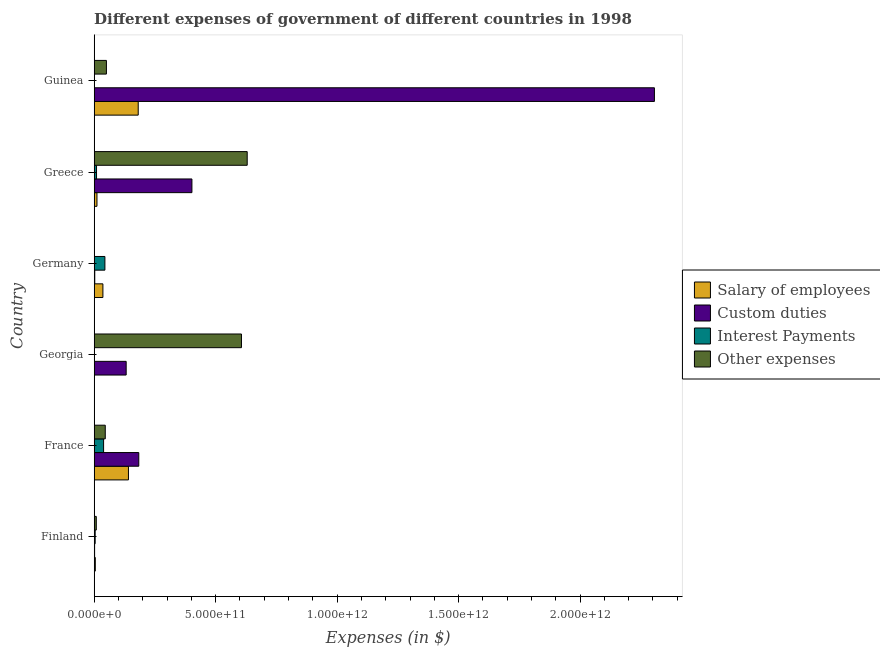How many different coloured bars are there?
Provide a short and direct response. 4. Are the number of bars per tick equal to the number of legend labels?
Give a very brief answer. Yes. Are the number of bars on each tick of the Y-axis equal?
Keep it short and to the point. Yes. How many bars are there on the 3rd tick from the top?
Make the answer very short. 4. How many bars are there on the 5th tick from the bottom?
Your answer should be very brief. 4. What is the label of the 2nd group of bars from the top?
Give a very brief answer. Greece. In how many cases, is the number of bars for a given country not equal to the number of legend labels?
Your response must be concise. 0. What is the amount spent on interest payments in Guinea?
Provide a succinct answer. 1.26e+09. Across all countries, what is the maximum amount spent on other expenses?
Ensure brevity in your answer.  6.30e+11. Across all countries, what is the minimum amount spent on other expenses?
Give a very brief answer. 7.21e+08. In which country was the amount spent on custom duties minimum?
Give a very brief answer. Finland. What is the total amount spent on interest payments in the graph?
Your answer should be very brief. 9.78e+1. What is the difference between the amount spent on salary of employees in Georgia and that in Guinea?
Make the answer very short. -1.81e+11. What is the difference between the amount spent on salary of employees in Germany and the amount spent on interest payments in France?
Your response must be concise. -2.83e+09. What is the average amount spent on interest payments per country?
Offer a very short reply. 1.63e+1. What is the difference between the amount spent on custom duties and amount spent on salary of employees in Germany?
Offer a terse response. -3.35e+1. What is the ratio of the amount spent on interest payments in France to that in Germany?
Keep it short and to the point. 0.88. What is the difference between the highest and the second highest amount spent on other expenses?
Provide a short and direct response. 2.36e+1. What is the difference between the highest and the lowest amount spent on other expenses?
Offer a very short reply. 6.29e+11. In how many countries, is the amount spent on custom duties greater than the average amount spent on custom duties taken over all countries?
Offer a very short reply. 1. Is the sum of the amount spent on interest payments in France and Germany greater than the maximum amount spent on other expenses across all countries?
Offer a terse response. No. Is it the case that in every country, the sum of the amount spent on interest payments and amount spent on other expenses is greater than the sum of amount spent on custom duties and amount spent on salary of employees?
Keep it short and to the point. No. What does the 3rd bar from the top in Germany represents?
Provide a short and direct response. Custom duties. What does the 1st bar from the bottom in Greece represents?
Provide a succinct answer. Salary of employees. Is it the case that in every country, the sum of the amount spent on salary of employees and amount spent on custom duties is greater than the amount spent on interest payments?
Provide a short and direct response. No. What is the difference between two consecutive major ticks on the X-axis?
Provide a succinct answer. 5.00e+11. Does the graph contain any zero values?
Provide a short and direct response. No. How many legend labels are there?
Give a very brief answer. 4. How are the legend labels stacked?
Make the answer very short. Vertical. What is the title of the graph?
Your answer should be very brief. Different expenses of government of different countries in 1998. What is the label or title of the X-axis?
Your answer should be very brief. Expenses (in $). What is the Expenses (in $) in Salary of employees in Finland?
Your answer should be very brief. 4.56e+09. What is the Expenses (in $) in Custom duties in Finland?
Ensure brevity in your answer.  1.68e+09. What is the Expenses (in $) in Interest Payments in Finland?
Make the answer very short. 4.01e+09. What is the Expenses (in $) in Other expenses in Finland?
Provide a short and direct response. 8.61e+09. What is the Expenses (in $) of Salary of employees in France?
Provide a succinct answer. 1.41e+11. What is the Expenses (in $) in Custom duties in France?
Offer a terse response. 1.84e+11. What is the Expenses (in $) in Interest Payments in France?
Your answer should be compact. 3.87e+1. What is the Expenses (in $) of Other expenses in France?
Provide a short and direct response. 4.56e+1. What is the Expenses (in $) of Salary of employees in Georgia?
Your answer should be compact. 8.04e+07. What is the Expenses (in $) in Custom duties in Georgia?
Provide a succinct answer. 1.32e+11. What is the Expenses (in $) in Interest Payments in Georgia?
Offer a very short reply. 1.28e+08. What is the Expenses (in $) in Other expenses in Georgia?
Keep it short and to the point. 6.06e+11. What is the Expenses (in $) of Salary of employees in Germany?
Your answer should be very brief. 3.58e+1. What is the Expenses (in $) of Custom duties in Germany?
Ensure brevity in your answer.  2.33e+09. What is the Expenses (in $) in Interest Payments in Germany?
Make the answer very short. 4.41e+1. What is the Expenses (in $) of Other expenses in Germany?
Keep it short and to the point. 7.21e+08. What is the Expenses (in $) in Salary of employees in Greece?
Your answer should be very brief. 1.14e+1. What is the Expenses (in $) in Custom duties in Greece?
Your answer should be very brief. 4.02e+11. What is the Expenses (in $) of Interest Payments in Greece?
Make the answer very short. 9.62e+09. What is the Expenses (in $) of Other expenses in Greece?
Ensure brevity in your answer.  6.30e+11. What is the Expenses (in $) in Salary of employees in Guinea?
Your answer should be very brief. 1.81e+11. What is the Expenses (in $) of Custom duties in Guinea?
Keep it short and to the point. 2.31e+12. What is the Expenses (in $) in Interest Payments in Guinea?
Give a very brief answer. 1.26e+09. What is the Expenses (in $) of Other expenses in Guinea?
Offer a very short reply. 5.03e+1. Across all countries, what is the maximum Expenses (in $) of Salary of employees?
Keep it short and to the point. 1.81e+11. Across all countries, what is the maximum Expenses (in $) in Custom duties?
Offer a very short reply. 2.31e+12. Across all countries, what is the maximum Expenses (in $) in Interest Payments?
Offer a terse response. 4.41e+1. Across all countries, what is the maximum Expenses (in $) of Other expenses?
Give a very brief answer. 6.30e+11. Across all countries, what is the minimum Expenses (in $) of Salary of employees?
Offer a very short reply. 8.04e+07. Across all countries, what is the minimum Expenses (in $) in Custom duties?
Your response must be concise. 1.68e+09. Across all countries, what is the minimum Expenses (in $) in Interest Payments?
Your answer should be very brief. 1.28e+08. Across all countries, what is the minimum Expenses (in $) of Other expenses?
Provide a succinct answer. 7.21e+08. What is the total Expenses (in $) in Salary of employees in the graph?
Offer a terse response. 3.74e+11. What is the total Expenses (in $) of Custom duties in the graph?
Ensure brevity in your answer.  3.03e+12. What is the total Expenses (in $) in Interest Payments in the graph?
Your answer should be compact. 9.78e+1. What is the total Expenses (in $) in Other expenses in the graph?
Give a very brief answer. 1.34e+12. What is the difference between the Expenses (in $) in Salary of employees in Finland and that in France?
Provide a succinct answer. -1.36e+11. What is the difference between the Expenses (in $) of Custom duties in Finland and that in France?
Make the answer very short. -1.82e+11. What is the difference between the Expenses (in $) in Interest Payments in Finland and that in France?
Your response must be concise. -3.47e+1. What is the difference between the Expenses (in $) in Other expenses in Finland and that in France?
Ensure brevity in your answer.  -3.69e+1. What is the difference between the Expenses (in $) in Salary of employees in Finland and that in Georgia?
Keep it short and to the point. 4.47e+09. What is the difference between the Expenses (in $) of Custom duties in Finland and that in Georgia?
Give a very brief answer. -1.30e+11. What is the difference between the Expenses (in $) in Interest Payments in Finland and that in Georgia?
Make the answer very short. 3.88e+09. What is the difference between the Expenses (in $) in Other expenses in Finland and that in Georgia?
Make the answer very short. -5.98e+11. What is the difference between the Expenses (in $) of Salary of employees in Finland and that in Germany?
Provide a succinct answer. -3.13e+1. What is the difference between the Expenses (in $) of Custom duties in Finland and that in Germany?
Ensure brevity in your answer.  -6.47e+08. What is the difference between the Expenses (in $) of Interest Payments in Finland and that in Germany?
Make the answer very short. -4.01e+1. What is the difference between the Expenses (in $) in Other expenses in Finland and that in Germany?
Give a very brief answer. 7.89e+09. What is the difference between the Expenses (in $) of Salary of employees in Finland and that in Greece?
Offer a very short reply. -6.83e+09. What is the difference between the Expenses (in $) in Custom duties in Finland and that in Greece?
Provide a succinct answer. -4.01e+11. What is the difference between the Expenses (in $) in Interest Payments in Finland and that in Greece?
Your answer should be very brief. -5.62e+09. What is the difference between the Expenses (in $) in Other expenses in Finland and that in Greece?
Your response must be concise. -6.21e+11. What is the difference between the Expenses (in $) of Salary of employees in Finland and that in Guinea?
Your response must be concise. -1.77e+11. What is the difference between the Expenses (in $) in Custom duties in Finland and that in Guinea?
Provide a short and direct response. -2.30e+12. What is the difference between the Expenses (in $) of Interest Payments in Finland and that in Guinea?
Your answer should be compact. 2.74e+09. What is the difference between the Expenses (in $) in Other expenses in Finland and that in Guinea?
Make the answer very short. -4.17e+1. What is the difference between the Expenses (in $) in Salary of employees in France and that in Georgia?
Provide a succinct answer. 1.41e+11. What is the difference between the Expenses (in $) in Custom duties in France and that in Georgia?
Keep it short and to the point. 5.19e+1. What is the difference between the Expenses (in $) of Interest Payments in France and that in Georgia?
Your response must be concise. 3.85e+1. What is the difference between the Expenses (in $) of Other expenses in France and that in Georgia?
Provide a short and direct response. -5.61e+11. What is the difference between the Expenses (in $) of Salary of employees in France and that in Germany?
Provide a succinct answer. 1.05e+11. What is the difference between the Expenses (in $) of Custom duties in France and that in Germany?
Your response must be concise. 1.81e+11. What is the difference between the Expenses (in $) of Interest Payments in France and that in Germany?
Keep it short and to the point. -5.44e+09. What is the difference between the Expenses (in $) of Other expenses in France and that in Germany?
Keep it short and to the point. 4.48e+1. What is the difference between the Expenses (in $) in Salary of employees in France and that in Greece?
Give a very brief answer. 1.30e+11. What is the difference between the Expenses (in $) in Custom duties in France and that in Greece?
Provide a short and direct response. -2.19e+11. What is the difference between the Expenses (in $) of Interest Payments in France and that in Greece?
Keep it short and to the point. 2.90e+1. What is the difference between the Expenses (in $) in Other expenses in France and that in Greece?
Make the answer very short. -5.84e+11. What is the difference between the Expenses (in $) in Salary of employees in France and that in Guinea?
Give a very brief answer. -4.02e+1. What is the difference between the Expenses (in $) of Custom duties in France and that in Guinea?
Offer a terse response. -2.12e+12. What is the difference between the Expenses (in $) in Interest Payments in France and that in Guinea?
Your answer should be compact. 3.74e+1. What is the difference between the Expenses (in $) in Other expenses in France and that in Guinea?
Keep it short and to the point. -4.75e+09. What is the difference between the Expenses (in $) of Salary of employees in Georgia and that in Germany?
Ensure brevity in your answer.  -3.57e+1. What is the difference between the Expenses (in $) in Custom duties in Georgia and that in Germany?
Your answer should be compact. 1.29e+11. What is the difference between the Expenses (in $) of Interest Payments in Georgia and that in Germany?
Give a very brief answer. -4.40e+1. What is the difference between the Expenses (in $) of Other expenses in Georgia and that in Germany?
Your response must be concise. 6.05e+11. What is the difference between the Expenses (in $) of Salary of employees in Georgia and that in Greece?
Keep it short and to the point. -1.13e+1. What is the difference between the Expenses (in $) in Custom duties in Georgia and that in Greece?
Your answer should be very brief. -2.71e+11. What is the difference between the Expenses (in $) in Interest Payments in Georgia and that in Greece?
Offer a terse response. -9.49e+09. What is the difference between the Expenses (in $) of Other expenses in Georgia and that in Greece?
Your answer should be very brief. -2.36e+1. What is the difference between the Expenses (in $) in Salary of employees in Georgia and that in Guinea?
Ensure brevity in your answer.  -1.81e+11. What is the difference between the Expenses (in $) in Custom duties in Georgia and that in Guinea?
Keep it short and to the point. -2.17e+12. What is the difference between the Expenses (in $) of Interest Payments in Georgia and that in Guinea?
Your answer should be very brief. -1.14e+09. What is the difference between the Expenses (in $) in Other expenses in Georgia and that in Guinea?
Your answer should be very brief. 5.56e+11. What is the difference between the Expenses (in $) in Salary of employees in Germany and that in Greece?
Give a very brief answer. 2.44e+1. What is the difference between the Expenses (in $) in Custom duties in Germany and that in Greece?
Your answer should be very brief. -4.00e+11. What is the difference between the Expenses (in $) in Interest Payments in Germany and that in Greece?
Your answer should be compact. 3.45e+1. What is the difference between the Expenses (in $) of Other expenses in Germany and that in Greece?
Make the answer very short. -6.29e+11. What is the difference between the Expenses (in $) in Salary of employees in Germany and that in Guinea?
Ensure brevity in your answer.  -1.45e+11. What is the difference between the Expenses (in $) of Custom duties in Germany and that in Guinea?
Your answer should be very brief. -2.30e+12. What is the difference between the Expenses (in $) of Interest Payments in Germany and that in Guinea?
Your response must be concise. 4.28e+1. What is the difference between the Expenses (in $) in Other expenses in Germany and that in Guinea?
Provide a short and direct response. -4.96e+1. What is the difference between the Expenses (in $) in Salary of employees in Greece and that in Guinea?
Make the answer very short. -1.70e+11. What is the difference between the Expenses (in $) in Custom duties in Greece and that in Guinea?
Your answer should be compact. -1.90e+12. What is the difference between the Expenses (in $) of Interest Payments in Greece and that in Guinea?
Offer a terse response. 8.36e+09. What is the difference between the Expenses (in $) in Other expenses in Greece and that in Guinea?
Offer a very short reply. 5.80e+11. What is the difference between the Expenses (in $) of Salary of employees in Finland and the Expenses (in $) of Custom duties in France?
Make the answer very short. -1.79e+11. What is the difference between the Expenses (in $) of Salary of employees in Finland and the Expenses (in $) of Interest Payments in France?
Your response must be concise. -3.41e+1. What is the difference between the Expenses (in $) in Salary of employees in Finland and the Expenses (in $) in Other expenses in France?
Keep it short and to the point. -4.10e+1. What is the difference between the Expenses (in $) in Custom duties in Finland and the Expenses (in $) in Interest Payments in France?
Your answer should be very brief. -3.70e+1. What is the difference between the Expenses (in $) in Custom duties in Finland and the Expenses (in $) in Other expenses in France?
Your response must be concise. -4.39e+1. What is the difference between the Expenses (in $) in Interest Payments in Finland and the Expenses (in $) in Other expenses in France?
Offer a very short reply. -4.15e+1. What is the difference between the Expenses (in $) in Salary of employees in Finland and the Expenses (in $) in Custom duties in Georgia?
Provide a succinct answer. -1.27e+11. What is the difference between the Expenses (in $) of Salary of employees in Finland and the Expenses (in $) of Interest Payments in Georgia?
Your answer should be very brief. 4.43e+09. What is the difference between the Expenses (in $) in Salary of employees in Finland and the Expenses (in $) in Other expenses in Georgia?
Provide a short and direct response. -6.02e+11. What is the difference between the Expenses (in $) of Custom duties in Finland and the Expenses (in $) of Interest Payments in Georgia?
Provide a succinct answer. 1.55e+09. What is the difference between the Expenses (in $) of Custom duties in Finland and the Expenses (in $) of Other expenses in Georgia?
Keep it short and to the point. -6.05e+11. What is the difference between the Expenses (in $) in Interest Payments in Finland and the Expenses (in $) in Other expenses in Georgia?
Keep it short and to the point. -6.02e+11. What is the difference between the Expenses (in $) of Salary of employees in Finland and the Expenses (in $) of Custom duties in Germany?
Ensure brevity in your answer.  2.23e+09. What is the difference between the Expenses (in $) of Salary of employees in Finland and the Expenses (in $) of Interest Payments in Germany?
Make the answer very short. -3.95e+1. What is the difference between the Expenses (in $) of Salary of employees in Finland and the Expenses (in $) of Other expenses in Germany?
Your answer should be very brief. 3.83e+09. What is the difference between the Expenses (in $) in Custom duties in Finland and the Expenses (in $) in Interest Payments in Germany?
Your answer should be compact. -4.24e+1. What is the difference between the Expenses (in $) of Custom duties in Finland and the Expenses (in $) of Other expenses in Germany?
Offer a very short reply. 9.61e+08. What is the difference between the Expenses (in $) in Interest Payments in Finland and the Expenses (in $) in Other expenses in Germany?
Offer a very short reply. 3.29e+09. What is the difference between the Expenses (in $) in Salary of employees in Finland and the Expenses (in $) in Custom duties in Greece?
Offer a very short reply. -3.98e+11. What is the difference between the Expenses (in $) of Salary of employees in Finland and the Expenses (in $) of Interest Payments in Greece?
Ensure brevity in your answer.  -5.07e+09. What is the difference between the Expenses (in $) in Salary of employees in Finland and the Expenses (in $) in Other expenses in Greece?
Provide a succinct answer. -6.25e+11. What is the difference between the Expenses (in $) in Custom duties in Finland and the Expenses (in $) in Interest Payments in Greece?
Provide a short and direct response. -7.94e+09. What is the difference between the Expenses (in $) of Custom duties in Finland and the Expenses (in $) of Other expenses in Greece?
Your answer should be compact. -6.28e+11. What is the difference between the Expenses (in $) of Interest Payments in Finland and the Expenses (in $) of Other expenses in Greece?
Make the answer very short. -6.26e+11. What is the difference between the Expenses (in $) of Salary of employees in Finland and the Expenses (in $) of Custom duties in Guinea?
Offer a terse response. -2.30e+12. What is the difference between the Expenses (in $) of Salary of employees in Finland and the Expenses (in $) of Interest Payments in Guinea?
Make the answer very short. 3.29e+09. What is the difference between the Expenses (in $) in Salary of employees in Finland and the Expenses (in $) in Other expenses in Guinea?
Keep it short and to the point. -4.57e+1. What is the difference between the Expenses (in $) in Custom duties in Finland and the Expenses (in $) in Interest Payments in Guinea?
Your answer should be very brief. 4.18e+08. What is the difference between the Expenses (in $) of Custom duties in Finland and the Expenses (in $) of Other expenses in Guinea?
Provide a succinct answer. -4.86e+1. What is the difference between the Expenses (in $) of Interest Payments in Finland and the Expenses (in $) of Other expenses in Guinea?
Give a very brief answer. -4.63e+1. What is the difference between the Expenses (in $) of Salary of employees in France and the Expenses (in $) of Custom duties in Georgia?
Give a very brief answer. 9.43e+09. What is the difference between the Expenses (in $) in Salary of employees in France and the Expenses (in $) in Interest Payments in Georgia?
Your answer should be very brief. 1.41e+11. What is the difference between the Expenses (in $) of Salary of employees in France and the Expenses (in $) of Other expenses in Georgia?
Give a very brief answer. -4.65e+11. What is the difference between the Expenses (in $) in Custom duties in France and the Expenses (in $) in Interest Payments in Georgia?
Make the answer very short. 1.83e+11. What is the difference between the Expenses (in $) in Custom duties in France and the Expenses (in $) in Other expenses in Georgia?
Keep it short and to the point. -4.23e+11. What is the difference between the Expenses (in $) of Interest Payments in France and the Expenses (in $) of Other expenses in Georgia?
Offer a very short reply. -5.68e+11. What is the difference between the Expenses (in $) in Salary of employees in France and the Expenses (in $) in Custom duties in Germany?
Your response must be concise. 1.39e+11. What is the difference between the Expenses (in $) of Salary of employees in France and the Expenses (in $) of Interest Payments in Germany?
Give a very brief answer. 9.69e+1. What is the difference between the Expenses (in $) in Salary of employees in France and the Expenses (in $) in Other expenses in Germany?
Ensure brevity in your answer.  1.40e+11. What is the difference between the Expenses (in $) of Custom duties in France and the Expenses (in $) of Interest Payments in Germany?
Make the answer very short. 1.39e+11. What is the difference between the Expenses (in $) of Custom duties in France and the Expenses (in $) of Other expenses in Germany?
Your response must be concise. 1.83e+11. What is the difference between the Expenses (in $) of Interest Payments in France and the Expenses (in $) of Other expenses in Germany?
Your response must be concise. 3.79e+1. What is the difference between the Expenses (in $) in Salary of employees in France and the Expenses (in $) in Custom duties in Greece?
Give a very brief answer. -2.61e+11. What is the difference between the Expenses (in $) in Salary of employees in France and the Expenses (in $) in Interest Payments in Greece?
Provide a short and direct response. 1.31e+11. What is the difference between the Expenses (in $) of Salary of employees in France and the Expenses (in $) of Other expenses in Greece?
Offer a terse response. -4.89e+11. What is the difference between the Expenses (in $) of Custom duties in France and the Expenses (in $) of Interest Payments in Greece?
Keep it short and to the point. 1.74e+11. What is the difference between the Expenses (in $) of Custom duties in France and the Expenses (in $) of Other expenses in Greece?
Provide a succinct answer. -4.46e+11. What is the difference between the Expenses (in $) in Interest Payments in France and the Expenses (in $) in Other expenses in Greece?
Provide a short and direct response. -5.91e+11. What is the difference between the Expenses (in $) of Salary of employees in France and the Expenses (in $) of Custom duties in Guinea?
Ensure brevity in your answer.  -2.16e+12. What is the difference between the Expenses (in $) in Salary of employees in France and the Expenses (in $) in Interest Payments in Guinea?
Provide a short and direct response. 1.40e+11. What is the difference between the Expenses (in $) in Salary of employees in France and the Expenses (in $) in Other expenses in Guinea?
Your answer should be very brief. 9.07e+1. What is the difference between the Expenses (in $) in Custom duties in France and the Expenses (in $) in Interest Payments in Guinea?
Provide a short and direct response. 1.82e+11. What is the difference between the Expenses (in $) of Custom duties in France and the Expenses (in $) of Other expenses in Guinea?
Make the answer very short. 1.33e+11. What is the difference between the Expenses (in $) of Interest Payments in France and the Expenses (in $) of Other expenses in Guinea?
Offer a very short reply. -1.16e+1. What is the difference between the Expenses (in $) in Salary of employees in Georgia and the Expenses (in $) in Custom duties in Germany?
Ensure brevity in your answer.  -2.25e+09. What is the difference between the Expenses (in $) in Salary of employees in Georgia and the Expenses (in $) in Interest Payments in Germany?
Ensure brevity in your answer.  -4.40e+1. What is the difference between the Expenses (in $) in Salary of employees in Georgia and the Expenses (in $) in Other expenses in Germany?
Provide a short and direct response. -6.41e+08. What is the difference between the Expenses (in $) of Custom duties in Georgia and the Expenses (in $) of Interest Payments in Germany?
Your response must be concise. 8.75e+1. What is the difference between the Expenses (in $) of Custom duties in Georgia and the Expenses (in $) of Other expenses in Germany?
Keep it short and to the point. 1.31e+11. What is the difference between the Expenses (in $) of Interest Payments in Georgia and the Expenses (in $) of Other expenses in Germany?
Provide a succinct answer. -5.93e+08. What is the difference between the Expenses (in $) in Salary of employees in Georgia and the Expenses (in $) in Custom duties in Greece?
Provide a succinct answer. -4.02e+11. What is the difference between the Expenses (in $) of Salary of employees in Georgia and the Expenses (in $) of Interest Payments in Greece?
Ensure brevity in your answer.  -9.54e+09. What is the difference between the Expenses (in $) in Salary of employees in Georgia and the Expenses (in $) in Other expenses in Greece?
Ensure brevity in your answer.  -6.30e+11. What is the difference between the Expenses (in $) of Custom duties in Georgia and the Expenses (in $) of Interest Payments in Greece?
Your answer should be compact. 1.22e+11. What is the difference between the Expenses (in $) in Custom duties in Georgia and the Expenses (in $) in Other expenses in Greece?
Your answer should be very brief. -4.98e+11. What is the difference between the Expenses (in $) in Interest Payments in Georgia and the Expenses (in $) in Other expenses in Greece?
Offer a very short reply. -6.30e+11. What is the difference between the Expenses (in $) in Salary of employees in Georgia and the Expenses (in $) in Custom duties in Guinea?
Your response must be concise. -2.31e+12. What is the difference between the Expenses (in $) in Salary of employees in Georgia and the Expenses (in $) in Interest Payments in Guinea?
Make the answer very short. -1.18e+09. What is the difference between the Expenses (in $) of Salary of employees in Georgia and the Expenses (in $) of Other expenses in Guinea?
Provide a short and direct response. -5.02e+1. What is the difference between the Expenses (in $) in Custom duties in Georgia and the Expenses (in $) in Interest Payments in Guinea?
Provide a succinct answer. 1.30e+11. What is the difference between the Expenses (in $) in Custom duties in Georgia and the Expenses (in $) in Other expenses in Guinea?
Your response must be concise. 8.13e+1. What is the difference between the Expenses (in $) of Interest Payments in Georgia and the Expenses (in $) of Other expenses in Guinea?
Your response must be concise. -5.02e+1. What is the difference between the Expenses (in $) of Salary of employees in Germany and the Expenses (in $) of Custom duties in Greece?
Offer a terse response. -3.66e+11. What is the difference between the Expenses (in $) of Salary of employees in Germany and the Expenses (in $) of Interest Payments in Greece?
Keep it short and to the point. 2.62e+1. What is the difference between the Expenses (in $) of Salary of employees in Germany and the Expenses (in $) of Other expenses in Greece?
Give a very brief answer. -5.94e+11. What is the difference between the Expenses (in $) in Custom duties in Germany and the Expenses (in $) in Interest Payments in Greece?
Ensure brevity in your answer.  -7.29e+09. What is the difference between the Expenses (in $) of Custom duties in Germany and the Expenses (in $) of Other expenses in Greece?
Offer a very short reply. -6.27e+11. What is the difference between the Expenses (in $) of Interest Payments in Germany and the Expenses (in $) of Other expenses in Greece?
Your response must be concise. -5.86e+11. What is the difference between the Expenses (in $) in Salary of employees in Germany and the Expenses (in $) in Custom duties in Guinea?
Offer a very short reply. -2.27e+12. What is the difference between the Expenses (in $) of Salary of employees in Germany and the Expenses (in $) of Interest Payments in Guinea?
Ensure brevity in your answer.  3.46e+1. What is the difference between the Expenses (in $) of Salary of employees in Germany and the Expenses (in $) of Other expenses in Guinea?
Give a very brief answer. -1.45e+1. What is the difference between the Expenses (in $) of Custom duties in Germany and the Expenses (in $) of Interest Payments in Guinea?
Your answer should be compact. 1.06e+09. What is the difference between the Expenses (in $) in Custom duties in Germany and the Expenses (in $) in Other expenses in Guinea?
Your response must be concise. -4.80e+1. What is the difference between the Expenses (in $) in Interest Payments in Germany and the Expenses (in $) in Other expenses in Guinea?
Your answer should be compact. -6.20e+09. What is the difference between the Expenses (in $) in Salary of employees in Greece and the Expenses (in $) in Custom duties in Guinea?
Ensure brevity in your answer.  -2.29e+12. What is the difference between the Expenses (in $) in Salary of employees in Greece and the Expenses (in $) in Interest Payments in Guinea?
Offer a very short reply. 1.01e+1. What is the difference between the Expenses (in $) of Salary of employees in Greece and the Expenses (in $) of Other expenses in Guinea?
Offer a very short reply. -3.89e+1. What is the difference between the Expenses (in $) in Custom duties in Greece and the Expenses (in $) in Interest Payments in Guinea?
Offer a very short reply. 4.01e+11. What is the difference between the Expenses (in $) of Custom duties in Greece and the Expenses (in $) of Other expenses in Guinea?
Keep it short and to the point. 3.52e+11. What is the difference between the Expenses (in $) of Interest Payments in Greece and the Expenses (in $) of Other expenses in Guinea?
Ensure brevity in your answer.  -4.07e+1. What is the average Expenses (in $) of Salary of employees per country?
Your answer should be compact. 6.23e+1. What is the average Expenses (in $) of Custom duties per country?
Provide a short and direct response. 5.05e+11. What is the average Expenses (in $) of Interest Payments per country?
Your answer should be very brief. 1.63e+1. What is the average Expenses (in $) of Other expenses per country?
Offer a very short reply. 2.24e+11. What is the difference between the Expenses (in $) of Salary of employees and Expenses (in $) of Custom duties in Finland?
Provide a succinct answer. 2.87e+09. What is the difference between the Expenses (in $) of Salary of employees and Expenses (in $) of Interest Payments in Finland?
Your response must be concise. 5.48e+08. What is the difference between the Expenses (in $) of Salary of employees and Expenses (in $) of Other expenses in Finland?
Give a very brief answer. -4.06e+09. What is the difference between the Expenses (in $) of Custom duties and Expenses (in $) of Interest Payments in Finland?
Keep it short and to the point. -2.32e+09. What is the difference between the Expenses (in $) in Custom duties and Expenses (in $) in Other expenses in Finland?
Make the answer very short. -6.93e+09. What is the difference between the Expenses (in $) in Interest Payments and Expenses (in $) in Other expenses in Finland?
Your response must be concise. -4.60e+09. What is the difference between the Expenses (in $) in Salary of employees and Expenses (in $) in Custom duties in France?
Keep it short and to the point. -4.25e+1. What is the difference between the Expenses (in $) of Salary of employees and Expenses (in $) of Interest Payments in France?
Your response must be concise. 1.02e+11. What is the difference between the Expenses (in $) in Salary of employees and Expenses (in $) in Other expenses in France?
Keep it short and to the point. 9.55e+1. What is the difference between the Expenses (in $) in Custom duties and Expenses (in $) in Interest Payments in France?
Your answer should be very brief. 1.45e+11. What is the difference between the Expenses (in $) of Custom duties and Expenses (in $) of Other expenses in France?
Provide a short and direct response. 1.38e+11. What is the difference between the Expenses (in $) of Interest Payments and Expenses (in $) of Other expenses in France?
Keep it short and to the point. -6.89e+09. What is the difference between the Expenses (in $) in Salary of employees and Expenses (in $) in Custom duties in Georgia?
Provide a short and direct response. -1.32e+11. What is the difference between the Expenses (in $) of Salary of employees and Expenses (in $) of Interest Payments in Georgia?
Your answer should be compact. -4.77e+07. What is the difference between the Expenses (in $) in Salary of employees and Expenses (in $) in Other expenses in Georgia?
Keep it short and to the point. -6.06e+11. What is the difference between the Expenses (in $) of Custom duties and Expenses (in $) of Interest Payments in Georgia?
Keep it short and to the point. 1.31e+11. What is the difference between the Expenses (in $) of Custom duties and Expenses (in $) of Other expenses in Georgia?
Make the answer very short. -4.75e+11. What is the difference between the Expenses (in $) of Interest Payments and Expenses (in $) of Other expenses in Georgia?
Ensure brevity in your answer.  -6.06e+11. What is the difference between the Expenses (in $) in Salary of employees and Expenses (in $) in Custom duties in Germany?
Give a very brief answer. 3.35e+1. What is the difference between the Expenses (in $) of Salary of employees and Expenses (in $) of Interest Payments in Germany?
Keep it short and to the point. -8.27e+09. What is the difference between the Expenses (in $) in Salary of employees and Expenses (in $) in Other expenses in Germany?
Make the answer very short. 3.51e+1. What is the difference between the Expenses (in $) in Custom duties and Expenses (in $) in Interest Payments in Germany?
Your response must be concise. -4.18e+1. What is the difference between the Expenses (in $) of Custom duties and Expenses (in $) of Other expenses in Germany?
Your answer should be very brief. 1.61e+09. What is the difference between the Expenses (in $) in Interest Payments and Expenses (in $) in Other expenses in Germany?
Your answer should be very brief. 4.34e+1. What is the difference between the Expenses (in $) of Salary of employees and Expenses (in $) of Custom duties in Greece?
Offer a terse response. -3.91e+11. What is the difference between the Expenses (in $) of Salary of employees and Expenses (in $) of Interest Payments in Greece?
Offer a terse response. 1.77e+09. What is the difference between the Expenses (in $) of Salary of employees and Expenses (in $) of Other expenses in Greece?
Make the answer very short. -6.18e+11. What is the difference between the Expenses (in $) of Custom duties and Expenses (in $) of Interest Payments in Greece?
Provide a short and direct response. 3.93e+11. What is the difference between the Expenses (in $) in Custom duties and Expenses (in $) in Other expenses in Greece?
Provide a succinct answer. -2.28e+11. What is the difference between the Expenses (in $) in Interest Payments and Expenses (in $) in Other expenses in Greece?
Provide a short and direct response. -6.20e+11. What is the difference between the Expenses (in $) in Salary of employees and Expenses (in $) in Custom duties in Guinea?
Provide a short and direct response. -2.12e+12. What is the difference between the Expenses (in $) in Salary of employees and Expenses (in $) in Interest Payments in Guinea?
Offer a terse response. 1.80e+11. What is the difference between the Expenses (in $) of Salary of employees and Expenses (in $) of Other expenses in Guinea?
Ensure brevity in your answer.  1.31e+11. What is the difference between the Expenses (in $) in Custom duties and Expenses (in $) in Interest Payments in Guinea?
Keep it short and to the point. 2.30e+12. What is the difference between the Expenses (in $) of Custom duties and Expenses (in $) of Other expenses in Guinea?
Your response must be concise. 2.26e+12. What is the difference between the Expenses (in $) in Interest Payments and Expenses (in $) in Other expenses in Guinea?
Your response must be concise. -4.90e+1. What is the ratio of the Expenses (in $) of Salary of employees in Finland to that in France?
Make the answer very short. 0.03. What is the ratio of the Expenses (in $) of Custom duties in Finland to that in France?
Your response must be concise. 0.01. What is the ratio of the Expenses (in $) of Interest Payments in Finland to that in France?
Your answer should be compact. 0.1. What is the ratio of the Expenses (in $) of Other expenses in Finland to that in France?
Ensure brevity in your answer.  0.19. What is the ratio of the Expenses (in $) in Salary of employees in Finland to that in Georgia?
Provide a short and direct response. 56.65. What is the ratio of the Expenses (in $) in Custom duties in Finland to that in Georgia?
Provide a short and direct response. 0.01. What is the ratio of the Expenses (in $) in Interest Payments in Finland to that in Georgia?
Offer a terse response. 31.28. What is the ratio of the Expenses (in $) of Other expenses in Finland to that in Georgia?
Offer a terse response. 0.01. What is the ratio of the Expenses (in $) in Salary of employees in Finland to that in Germany?
Offer a very short reply. 0.13. What is the ratio of the Expenses (in $) in Custom duties in Finland to that in Germany?
Provide a short and direct response. 0.72. What is the ratio of the Expenses (in $) of Interest Payments in Finland to that in Germany?
Your answer should be compact. 0.09. What is the ratio of the Expenses (in $) in Other expenses in Finland to that in Germany?
Your answer should be compact. 11.94. What is the ratio of the Expenses (in $) in Salary of employees in Finland to that in Greece?
Your answer should be very brief. 0.4. What is the ratio of the Expenses (in $) of Custom duties in Finland to that in Greece?
Your response must be concise. 0. What is the ratio of the Expenses (in $) of Interest Payments in Finland to that in Greece?
Provide a short and direct response. 0.42. What is the ratio of the Expenses (in $) of Other expenses in Finland to that in Greece?
Offer a terse response. 0.01. What is the ratio of the Expenses (in $) in Salary of employees in Finland to that in Guinea?
Ensure brevity in your answer.  0.03. What is the ratio of the Expenses (in $) in Custom duties in Finland to that in Guinea?
Keep it short and to the point. 0. What is the ratio of the Expenses (in $) in Interest Payments in Finland to that in Guinea?
Give a very brief answer. 3.17. What is the ratio of the Expenses (in $) of Other expenses in Finland to that in Guinea?
Provide a short and direct response. 0.17. What is the ratio of the Expenses (in $) in Salary of employees in France to that in Georgia?
Provide a succinct answer. 1754.05. What is the ratio of the Expenses (in $) of Custom duties in France to that in Georgia?
Ensure brevity in your answer.  1.39. What is the ratio of the Expenses (in $) in Interest Payments in France to that in Georgia?
Give a very brief answer. 301.79. What is the ratio of the Expenses (in $) in Other expenses in France to that in Georgia?
Offer a very short reply. 0.08. What is the ratio of the Expenses (in $) in Salary of employees in France to that in Germany?
Provide a succinct answer. 3.94. What is the ratio of the Expenses (in $) of Custom duties in France to that in Germany?
Offer a very short reply. 78.81. What is the ratio of the Expenses (in $) of Interest Payments in France to that in Germany?
Keep it short and to the point. 0.88. What is the ratio of the Expenses (in $) in Other expenses in France to that in Germany?
Your answer should be very brief. 63.18. What is the ratio of the Expenses (in $) of Salary of employees in France to that in Greece?
Your response must be concise. 12.38. What is the ratio of the Expenses (in $) of Custom duties in France to that in Greece?
Offer a very short reply. 0.46. What is the ratio of the Expenses (in $) of Interest Payments in France to that in Greece?
Give a very brief answer. 4.02. What is the ratio of the Expenses (in $) of Other expenses in France to that in Greece?
Offer a very short reply. 0.07. What is the ratio of the Expenses (in $) of Salary of employees in France to that in Guinea?
Keep it short and to the point. 0.78. What is the ratio of the Expenses (in $) of Custom duties in France to that in Guinea?
Provide a short and direct response. 0.08. What is the ratio of the Expenses (in $) of Interest Payments in France to that in Guinea?
Keep it short and to the point. 30.59. What is the ratio of the Expenses (in $) in Other expenses in France to that in Guinea?
Give a very brief answer. 0.91. What is the ratio of the Expenses (in $) in Salary of employees in Georgia to that in Germany?
Keep it short and to the point. 0. What is the ratio of the Expenses (in $) of Custom duties in Georgia to that in Germany?
Keep it short and to the point. 56.5. What is the ratio of the Expenses (in $) in Interest Payments in Georgia to that in Germany?
Your response must be concise. 0. What is the ratio of the Expenses (in $) in Other expenses in Georgia to that in Germany?
Your answer should be very brief. 840.78. What is the ratio of the Expenses (in $) in Salary of employees in Georgia to that in Greece?
Your response must be concise. 0.01. What is the ratio of the Expenses (in $) in Custom duties in Georgia to that in Greece?
Make the answer very short. 0.33. What is the ratio of the Expenses (in $) of Interest Payments in Georgia to that in Greece?
Offer a terse response. 0.01. What is the ratio of the Expenses (in $) in Other expenses in Georgia to that in Greece?
Offer a terse response. 0.96. What is the ratio of the Expenses (in $) in Salary of employees in Georgia to that in Guinea?
Your answer should be very brief. 0. What is the ratio of the Expenses (in $) in Custom duties in Georgia to that in Guinea?
Your response must be concise. 0.06. What is the ratio of the Expenses (in $) of Interest Payments in Georgia to that in Guinea?
Keep it short and to the point. 0.1. What is the ratio of the Expenses (in $) in Other expenses in Georgia to that in Guinea?
Give a very brief answer. 12.05. What is the ratio of the Expenses (in $) of Salary of employees in Germany to that in Greece?
Ensure brevity in your answer.  3.15. What is the ratio of the Expenses (in $) in Custom duties in Germany to that in Greece?
Your answer should be very brief. 0.01. What is the ratio of the Expenses (in $) of Interest Payments in Germany to that in Greece?
Provide a succinct answer. 4.58. What is the ratio of the Expenses (in $) in Other expenses in Germany to that in Greece?
Offer a very short reply. 0. What is the ratio of the Expenses (in $) in Salary of employees in Germany to that in Guinea?
Make the answer very short. 0.2. What is the ratio of the Expenses (in $) of Custom duties in Germany to that in Guinea?
Keep it short and to the point. 0. What is the ratio of the Expenses (in $) in Interest Payments in Germany to that in Guinea?
Your answer should be very brief. 34.89. What is the ratio of the Expenses (in $) of Other expenses in Germany to that in Guinea?
Make the answer very short. 0.01. What is the ratio of the Expenses (in $) of Salary of employees in Greece to that in Guinea?
Provide a short and direct response. 0.06. What is the ratio of the Expenses (in $) in Custom duties in Greece to that in Guinea?
Ensure brevity in your answer.  0.17. What is the ratio of the Expenses (in $) of Interest Payments in Greece to that in Guinea?
Your response must be concise. 7.61. What is the ratio of the Expenses (in $) of Other expenses in Greece to that in Guinea?
Give a very brief answer. 12.52. What is the difference between the highest and the second highest Expenses (in $) of Salary of employees?
Your response must be concise. 4.02e+1. What is the difference between the highest and the second highest Expenses (in $) of Custom duties?
Your response must be concise. 1.90e+12. What is the difference between the highest and the second highest Expenses (in $) in Interest Payments?
Offer a terse response. 5.44e+09. What is the difference between the highest and the second highest Expenses (in $) in Other expenses?
Make the answer very short. 2.36e+1. What is the difference between the highest and the lowest Expenses (in $) in Salary of employees?
Your answer should be compact. 1.81e+11. What is the difference between the highest and the lowest Expenses (in $) in Custom duties?
Your response must be concise. 2.30e+12. What is the difference between the highest and the lowest Expenses (in $) in Interest Payments?
Provide a short and direct response. 4.40e+1. What is the difference between the highest and the lowest Expenses (in $) in Other expenses?
Offer a very short reply. 6.29e+11. 